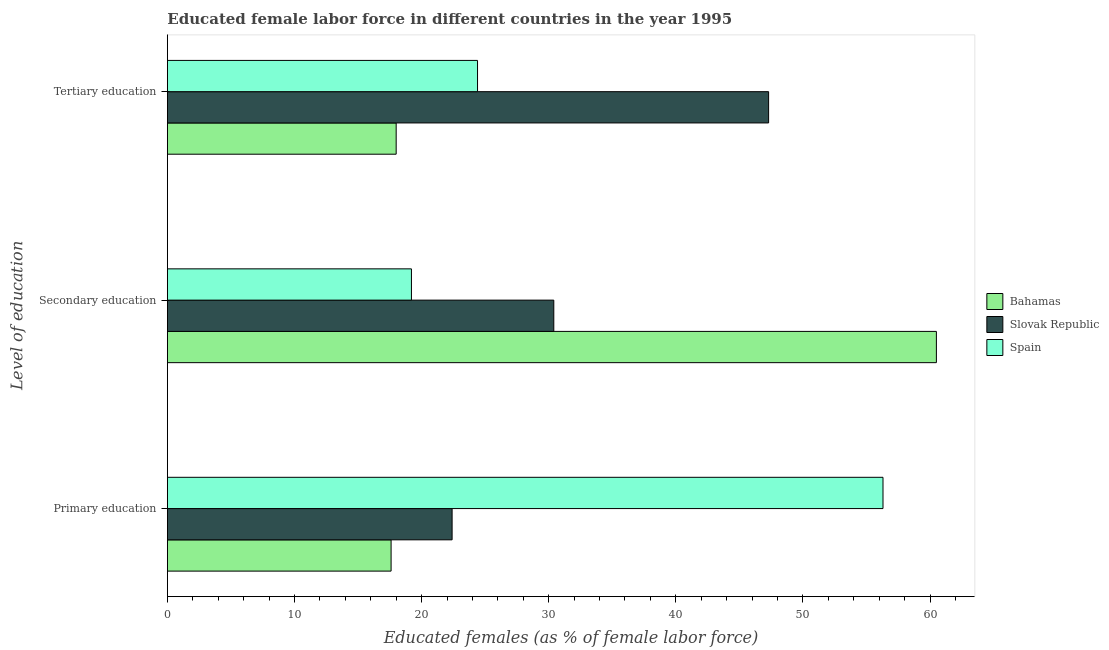How many different coloured bars are there?
Give a very brief answer. 3. How many groups of bars are there?
Keep it short and to the point. 3. Are the number of bars per tick equal to the number of legend labels?
Keep it short and to the point. Yes. Are the number of bars on each tick of the Y-axis equal?
Offer a very short reply. Yes. How many bars are there on the 3rd tick from the bottom?
Make the answer very short. 3. What is the label of the 3rd group of bars from the top?
Your answer should be compact. Primary education. Across all countries, what is the maximum percentage of female labor force who received secondary education?
Offer a very short reply. 60.5. Across all countries, what is the minimum percentage of female labor force who received tertiary education?
Provide a short and direct response. 18. In which country was the percentage of female labor force who received primary education maximum?
Provide a short and direct response. Spain. In which country was the percentage of female labor force who received primary education minimum?
Give a very brief answer. Bahamas. What is the total percentage of female labor force who received tertiary education in the graph?
Provide a short and direct response. 89.7. What is the difference between the percentage of female labor force who received tertiary education in Slovak Republic and that in Spain?
Provide a succinct answer. 22.9. What is the difference between the percentage of female labor force who received secondary education in Slovak Republic and the percentage of female labor force who received tertiary education in Spain?
Keep it short and to the point. 6. What is the average percentage of female labor force who received secondary education per country?
Make the answer very short. 36.7. What is the difference between the percentage of female labor force who received tertiary education and percentage of female labor force who received secondary education in Bahamas?
Give a very brief answer. -42.5. In how many countries, is the percentage of female labor force who received primary education greater than 12 %?
Provide a succinct answer. 3. What is the ratio of the percentage of female labor force who received primary education in Spain to that in Slovak Republic?
Provide a short and direct response. 2.51. Is the percentage of female labor force who received tertiary education in Spain less than that in Slovak Republic?
Your answer should be compact. Yes. Is the difference between the percentage of female labor force who received primary education in Slovak Republic and Spain greater than the difference between the percentage of female labor force who received tertiary education in Slovak Republic and Spain?
Your answer should be compact. No. What is the difference between the highest and the second highest percentage of female labor force who received tertiary education?
Your answer should be compact. 22.9. What is the difference between the highest and the lowest percentage of female labor force who received tertiary education?
Your response must be concise. 29.3. In how many countries, is the percentage of female labor force who received primary education greater than the average percentage of female labor force who received primary education taken over all countries?
Offer a terse response. 1. Is the sum of the percentage of female labor force who received tertiary education in Bahamas and Slovak Republic greater than the maximum percentage of female labor force who received primary education across all countries?
Make the answer very short. Yes. What does the 3rd bar from the top in Secondary education represents?
Your response must be concise. Bahamas. What does the 1st bar from the bottom in Secondary education represents?
Your answer should be compact. Bahamas. Is it the case that in every country, the sum of the percentage of female labor force who received primary education and percentage of female labor force who received secondary education is greater than the percentage of female labor force who received tertiary education?
Keep it short and to the point. Yes. How many countries are there in the graph?
Provide a succinct answer. 3. What is the difference between two consecutive major ticks on the X-axis?
Keep it short and to the point. 10. Are the values on the major ticks of X-axis written in scientific E-notation?
Your answer should be compact. No. Does the graph contain any zero values?
Your response must be concise. No. Does the graph contain grids?
Keep it short and to the point. No. Where does the legend appear in the graph?
Provide a short and direct response. Center right. How many legend labels are there?
Provide a succinct answer. 3. What is the title of the graph?
Give a very brief answer. Educated female labor force in different countries in the year 1995. What is the label or title of the X-axis?
Keep it short and to the point. Educated females (as % of female labor force). What is the label or title of the Y-axis?
Offer a very short reply. Level of education. What is the Educated females (as % of female labor force) in Bahamas in Primary education?
Make the answer very short. 17.6. What is the Educated females (as % of female labor force) of Slovak Republic in Primary education?
Offer a very short reply. 22.4. What is the Educated females (as % of female labor force) of Spain in Primary education?
Keep it short and to the point. 56.3. What is the Educated females (as % of female labor force) of Bahamas in Secondary education?
Provide a short and direct response. 60.5. What is the Educated females (as % of female labor force) of Slovak Republic in Secondary education?
Keep it short and to the point. 30.4. What is the Educated females (as % of female labor force) of Spain in Secondary education?
Your response must be concise. 19.2. What is the Educated females (as % of female labor force) in Slovak Republic in Tertiary education?
Make the answer very short. 47.3. What is the Educated females (as % of female labor force) in Spain in Tertiary education?
Ensure brevity in your answer.  24.4. Across all Level of education, what is the maximum Educated females (as % of female labor force) in Bahamas?
Offer a terse response. 60.5. Across all Level of education, what is the maximum Educated females (as % of female labor force) in Slovak Republic?
Provide a short and direct response. 47.3. Across all Level of education, what is the maximum Educated females (as % of female labor force) in Spain?
Your answer should be very brief. 56.3. Across all Level of education, what is the minimum Educated females (as % of female labor force) of Bahamas?
Provide a succinct answer. 17.6. Across all Level of education, what is the minimum Educated females (as % of female labor force) of Slovak Republic?
Your answer should be very brief. 22.4. Across all Level of education, what is the minimum Educated females (as % of female labor force) in Spain?
Ensure brevity in your answer.  19.2. What is the total Educated females (as % of female labor force) of Bahamas in the graph?
Keep it short and to the point. 96.1. What is the total Educated females (as % of female labor force) of Slovak Republic in the graph?
Give a very brief answer. 100.1. What is the total Educated females (as % of female labor force) of Spain in the graph?
Your answer should be compact. 99.9. What is the difference between the Educated females (as % of female labor force) in Bahamas in Primary education and that in Secondary education?
Offer a very short reply. -42.9. What is the difference between the Educated females (as % of female labor force) of Spain in Primary education and that in Secondary education?
Make the answer very short. 37.1. What is the difference between the Educated females (as % of female labor force) in Bahamas in Primary education and that in Tertiary education?
Give a very brief answer. -0.4. What is the difference between the Educated females (as % of female labor force) of Slovak Republic in Primary education and that in Tertiary education?
Make the answer very short. -24.9. What is the difference between the Educated females (as % of female labor force) in Spain in Primary education and that in Tertiary education?
Ensure brevity in your answer.  31.9. What is the difference between the Educated females (as % of female labor force) of Bahamas in Secondary education and that in Tertiary education?
Provide a short and direct response. 42.5. What is the difference between the Educated females (as % of female labor force) of Slovak Republic in Secondary education and that in Tertiary education?
Provide a short and direct response. -16.9. What is the difference between the Educated females (as % of female labor force) of Bahamas in Primary education and the Educated females (as % of female labor force) of Slovak Republic in Secondary education?
Keep it short and to the point. -12.8. What is the difference between the Educated females (as % of female labor force) of Bahamas in Primary education and the Educated females (as % of female labor force) of Spain in Secondary education?
Your answer should be compact. -1.6. What is the difference between the Educated females (as % of female labor force) of Slovak Republic in Primary education and the Educated females (as % of female labor force) of Spain in Secondary education?
Offer a very short reply. 3.2. What is the difference between the Educated females (as % of female labor force) of Bahamas in Primary education and the Educated females (as % of female labor force) of Slovak Republic in Tertiary education?
Offer a terse response. -29.7. What is the difference between the Educated females (as % of female labor force) in Slovak Republic in Primary education and the Educated females (as % of female labor force) in Spain in Tertiary education?
Offer a terse response. -2. What is the difference between the Educated females (as % of female labor force) in Bahamas in Secondary education and the Educated females (as % of female labor force) in Slovak Republic in Tertiary education?
Your answer should be compact. 13.2. What is the difference between the Educated females (as % of female labor force) in Bahamas in Secondary education and the Educated females (as % of female labor force) in Spain in Tertiary education?
Offer a terse response. 36.1. What is the difference between the Educated females (as % of female labor force) in Slovak Republic in Secondary education and the Educated females (as % of female labor force) in Spain in Tertiary education?
Provide a short and direct response. 6. What is the average Educated females (as % of female labor force) in Bahamas per Level of education?
Keep it short and to the point. 32.03. What is the average Educated females (as % of female labor force) of Slovak Republic per Level of education?
Make the answer very short. 33.37. What is the average Educated females (as % of female labor force) of Spain per Level of education?
Provide a succinct answer. 33.3. What is the difference between the Educated females (as % of female labor force) of Bahamas and Educated females (as % of female labor force) of Spain in Primary education?
Ensure brevity in your answer.  -38.7. What is the difference between the Educated females (as % of female labor force) in Slovak Republic and Educated females (as % of female labor force) in Spain in Primary education?
Your response must be concise. -33.9. What is the difference between the Educated females (as % of female labor force) in Bahamas and Educated females (as % of female labor force) in Slovak Republic in Secondary education?
Your answer should be compact. 30.1. What is the difference between the Educated females (as % of female labor force) of Bahamas and Educated females (as % of female labor force) of Spain in Secondary education?
Make the answer very short. 41.3. What is the difference between the Educated females (as % of female labor force) in Slovak Republic and Educated females (as % of female labor force) in Spain in Secondary education?
Your response must be concise. 11.2. What is the difference between the Educated females (as % of female labor force) in Bahamas and Educated females (as % of female labor force) in Slovak Republic in Tertiary education?
Your response must be concise. -29.3. What is the difference between the Educated females (as % of female labor force) in Slovak Republic and Educated females (as % of female labor force) in Spain in Tertiary education?
Keep it short and to the point. 22.9. What is the ratio of the Educated females (as % of female labor force) in Bahamas in Primary education to that in Secondary education?
Provide a short and direct response. 0.29. What is the ratio of the Educated females (as % of female labor force) of Slovak Republic in Primary education to that in Secondary education?
Your answer should be compact. 0.74. What is the ratio of the Educated females (as % of female labor force) in Spain in Primary education to that in Secondary education?
Offer a terse response. 2.93. What is the ratio of the Educated females (as % of female labor force) of Bahamas in Primary education to that in Tertiary education?
Offer a very short reply. 0.98. What is the ratio of the Educated females (as % of female labor force) in Slovak Republic in Primary education to that in Tertiary education?
Provide a succinct answer. 0.47. What is the ratio of the Educated females (as % of female labor force) of Spain in Primary education to that in Tertiary education?
Provide a short and direct response. 2.31. What is the ratio of the Educated females (as % of female labor force) of Bahamas in Secondary education to that in Tertiary education?
Make the answer very short. 3.36. What is the ratio of the Educated females (as % of female labor force) of Slovak Republic in Secondary education to that in Tertiary education?
Ensure brevity in your answer.  0.64. What is the ratio of the Educated females (as % of female labor force) of Spain in Secondary education to that in Tertiary education?
Your answer should be very brief. 0.79. What is the difference between the highest and the second highest Educated females (as % of female labor force) in Bahamas?
Your answer should be very brief. 42.5. What is the difference between the highest and the second highest Educated females (as % of female labor force) of Spain?
Your response must be concise. 31.9. What is the difference between the highest and the lowest Educated females (as % of female labor force) of Bahamas?
Offer a very short reply. 42.9. What is the difference between the highest and the lowest Educated females (as % of female labor force) in Slovak Republic?
Your answer should be compact. 24.9. What is the difference between the highest and the lowest Educated females (as % of female labor force) in Spain?
Ensure brevity in your answer.  37.1. 